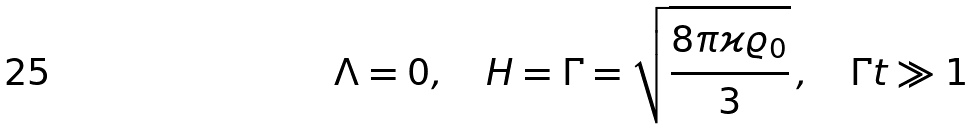Convert formula to latex. <formula><loc_0><loc_0><loc_500><loc_500>\Lambda = 0 , \quad H = \Gamma = \sqrt { \frac { 8 \pi \varkappa \varrho _ { 0 } } { 3 } } \, , \quad \Gamma t \gg 1</formula> 